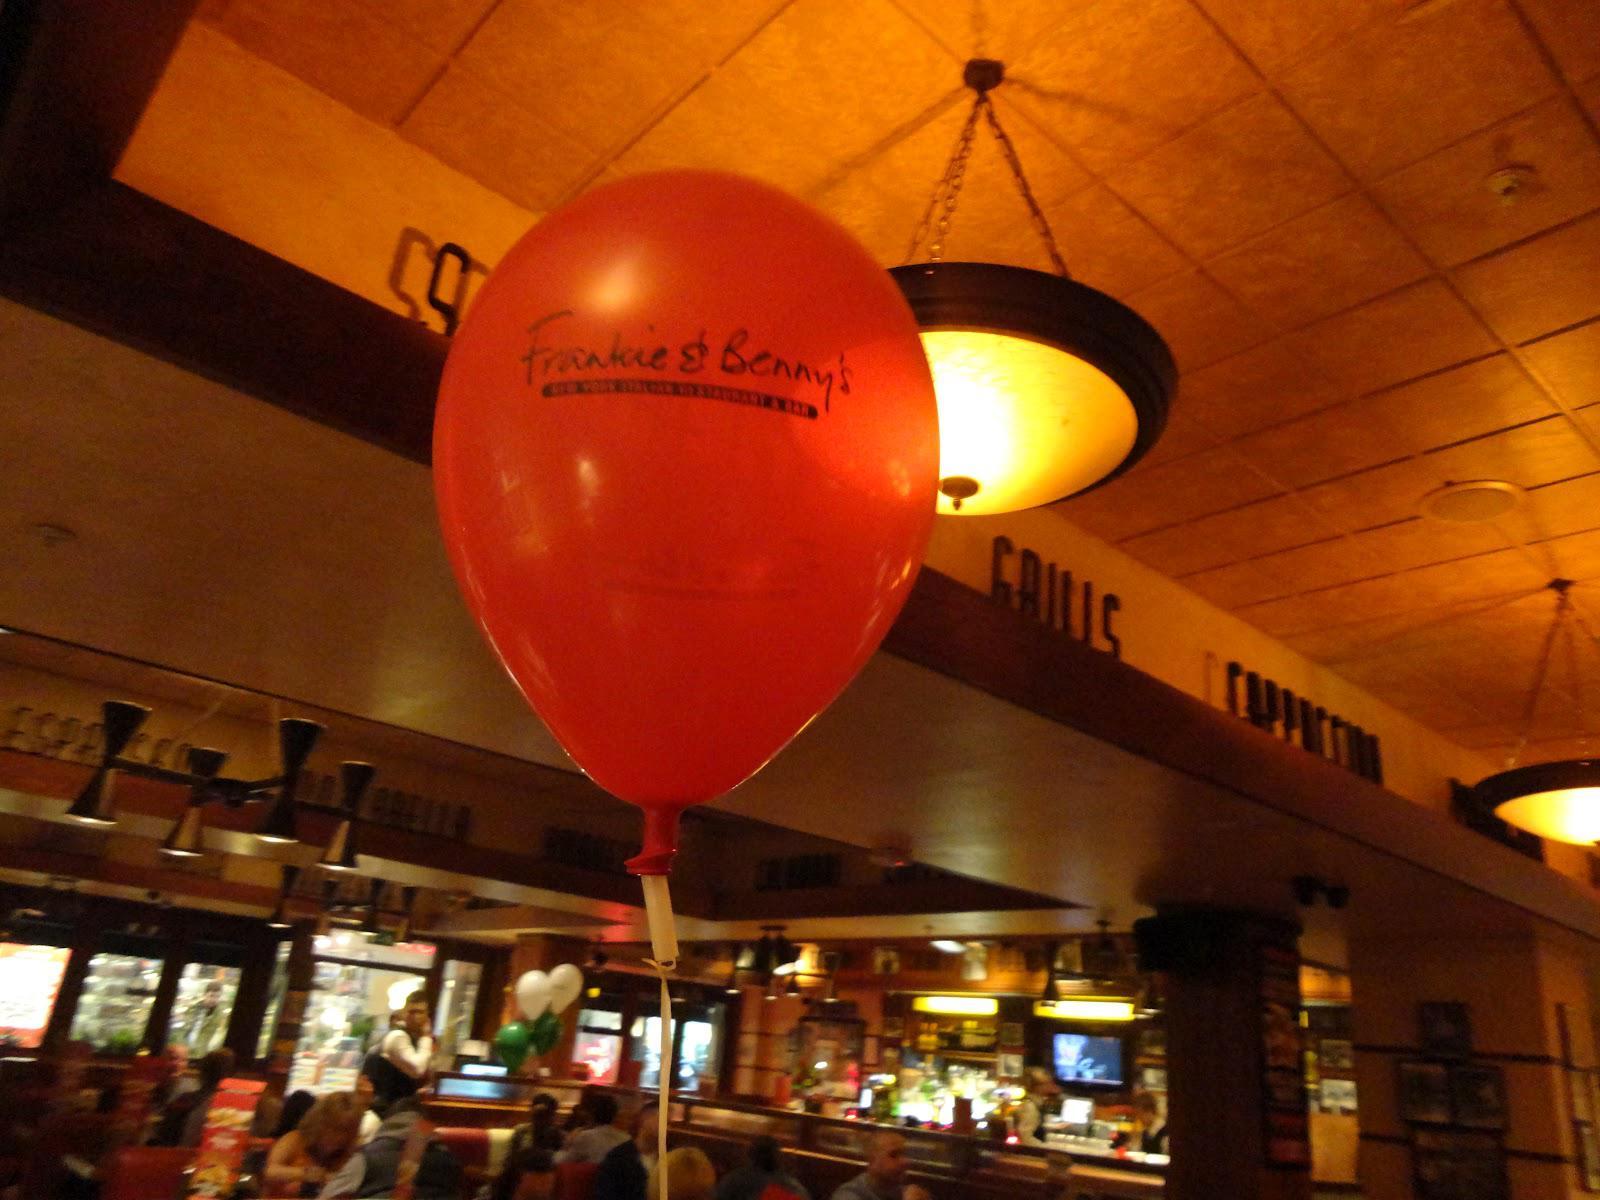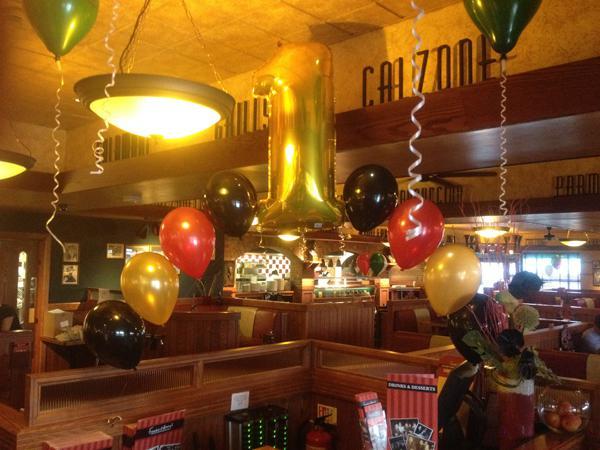The first image is the image on the left, the second image is the image on the right. Given the left and right images, does the statement "The left and right image contains no more than six balloons." hold true? Answer yes or no. No. The first image is the image on the left, the second image is the image on the right. Considering the images on both sides, is "The left image features no more than four balloons in a restaurant scene, including red and green balloons, and the right image includes a red balloon to the left of a white balloon." valid? Answer yes or no. No. 